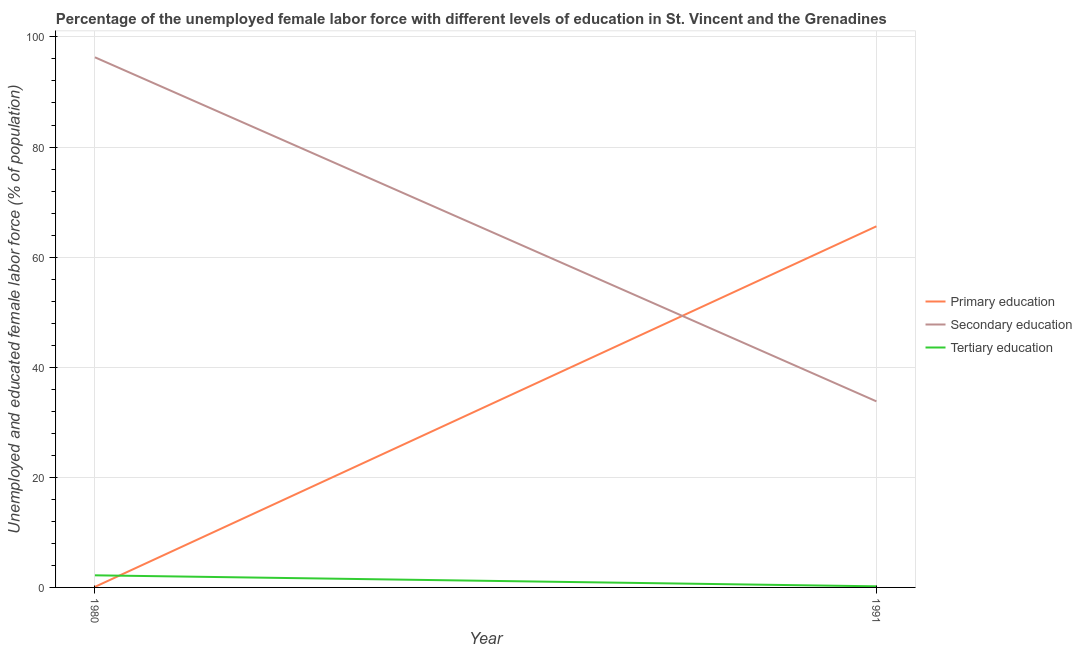How many different coloured lines are there?
Your answer should be compact. 3. Is the number of lines equal to the number of legend labels?
Your response must be concise. Yes. What is the percentage of female labor force who received tertiary education in 1980?
Ensure brevity in your answer.  2.2. Across all years, what is the maximum percentage of female labor force who received secondary education?
Give a very brief answer. 96.3. Across all years, what is the minimum percentage of female labor force who received secondary education?
Your answer should be compact. 33.8. What is the total percentage of female labor force who received primary education in the graph?
Your answer should be very brief. 65.7. What is the difference between the percentage of female labor force who received tertiary education in 1980 and that in 1991?
Your answer should be compact. 2. What is the difference between the percentage of female labor force who received primary education in 1980 and the percentage of female labor force who received tertiary education in 1991?
Offer a terse response. -0.1. What is the average percentage of female labor force who received secondary education per year?
Provide a succinct answer. 65.05. In the year 1991, what is the difference between the percentage of female labor force who received secondary education and percentage of female labor force who received primary education?
Provide a short and direct response. -31.8. In how many years, is the percentage of female labor force who received primary education greater than 76 %?
Provide a succinct answer. 0. What is the ratio of the percentage of female labor force who received primary education in 1980 to that in 1991?
Your response must be concise. 0. Is it the case that in every year, the sum of the percentage of female labor force who received primary education and percentage of female labor force who received secondary education is greater than the percentage of female labor force who received tertiary education?
Provide a succinct answer. Yes. Does the percentage of female labor force who received primary education monotonically increase over the years?
Provide a short and direct response. Yes. Is the percentage of female labor force who received tertiary education strictly less than the percentage of female labor force who received secondary education over the years?
Ensure brevity in your answer.  Yes. Are the values on the major ticks of Y-axis written in scientific E-notation?
Provide a short and direct response. No. Does the graph contain any zero values?
Provide a short and direct response. No. Does the graph contain grids?
Give a very brief answer. Yes. How many legend labels are there?
Your response must be concise. 3. How are the legend labels stacked?
Provide a short and direct response. Vertical. What is the title of the graph?
Offer a very short reply. Percentage of the unemployed female labor force with different levels of education in St. Vincent and the Grenadines. What is the label or title of the X-axis?
Your answer should be compact. Year. What is the label or title of the Y-axis?
Make the answer very short. Unemployed and educated female labor force (% of population). What is the Unemployed and educated female labor force (% of population) in Primary education in 1980?
Offer a terse response. 0.1. What is the Unemployed and educated female labor force (% of population) of Secondary education in 1980?
Give a very brief answer. 96.3. What is the Unemployed and educated female labor force (% of population) in Tertiary education in 1980?
Provide a succinct answer. 2.2. What is the Unemployed and educated female labor force (% of population) of Primary education in 1991?
Ensure brevity in your answer.  65.6. What is the Unemployed and educated female labor force (% of population) of Secondary education in 1991?
Provide a succinct answer. 33.8. What is the Unemployed and educated female labor force (% of population) in Tertiary education in 1991?
Your response must be concise. 0.2. Across all years, what is the maximum Unemployed and educated female labor force (% of population) of Primary education?
Offer a terse response. 65.6. Across all years, what is the maximum Unemployed and educated female labor force (% of population) of Secondary education?
Make the answer very short. 96.3. Across all years, what is the maximum Unemployed and educated female labor force (% of population) of Tertiary education?
Provide a short and direct response. 2.2. Across all years, what is the minimum Unemployed and educated female labor force (% of population) of Primary education?
Provide a short and direct response. 0.1. Across all years, what is the minimum Unemployed and educated female labor force (% of population) in Secondary education?
Ensure brevity in your answer.  33.8. Across all years, what is the minimum Unemployed and educated female labor force (% of population) of Tertiary education?
Make the answer very short. 0.2. What is the total Unemployed and educated female labor force (% of population) of Primary education in the graph?
Make the answer very short. 65.7. What is the total Unemployed and educated female labor force (% of population) of Secondary education in the graph?
Provide a short and direct response. 130.1. What is the difference between the Unemployed and educated female labor force (% of population) of Primary education in 1980 and that in 1991?
Ensure brevity in your answer.  -65.5. What is the difference between the Unemployed and educated female labor force (% of population) in Secondary education in 1980 and that in 1991?
Provide a short and direct response. 62.5. What is the difference between the Unemployed and educated female labor force (% of population) in Primary education in 1980 and the Unemployed and educated female labor force (% of population) in Secondary education in 1991?
Provide a short and direct response. -33.7. What is the difference between the Unemployed and educated female labor force (% of population) in Secondary education in 1980 and the Unemployed and educated female labor force (% of population) in Tertiary education in 1991?
Provide a short and direct response. 96.1. What is the average Unemployed and educated female labor force (% of population) of Primary education per year?
Give a very brief answer. 32.85. What is the average Unemployed and educated female labor force (% of population) of Secondary education per year?
Offer a terse response. 65.05. In the year 1980, what is the difference between the Unemployed and educated female labor force (% of population) in Primary education and Unemployed and educated female labor force (% of population) in Secondary education?
Offer a very short reply. -96.2. In the year 1980, what is the difference between the Unemployed and educated female labor force (% of population) in Secondary education and Unemployed and educated female labor force (% of population) in Tertiary education?
Provide a succinct answer. 94.1. In the year 1991, what is the difference between the Unemployed and educated female labor force (% of population) in Primary education and Unemployed and educated female labor force (% of population) in Secondary education?
Offer a terse response. 31.8. In the year 1991, what is the difference between the Unemployed and educated female labor force (% of population) in Primary education and Unemployed and educated female labor force (% of population) in Tertiary education?
Offer a very short reply. 65.4. In the year 1991, what is the difference between the Unemployed and educated female labor force (% of population) in Secondary education and Unemployed and educated female labor force (% of population) in Tertiary education?
Provide a short and direct response. 33.6. What is the ratio of the Unemployed and educated female labor force (% of population) in Primary education in 1980 to that in 1991?
Make the answer very short. 0. What is the ratio of the Unemployed and educated female labor force (% of population) of Secondary education in 1980 to that in 1991?
Your answer should be compact. 2.85. What is the difference between the highest and the second highest Unemployed and educated female labor force (% of population) in Primary education?
Provide a short and direct response. 65.5. What is the difference between the highest and the second highest Unemployed and educated female labor force (% of population) in Secondary education?
Provide a short and direct response. 62.5. What is the difference between the highest and the second highest Unemployed and educated female labor force (% of population) in Tertiary education?
Your answer should be very brief. 2. What is the difference between the highest and the lowest Unemployed and educated female labor force (% of population) of Primary education?
Give a very brief answer. 65.5. What is the difference between the highest and the lowest Unemployed and educated female labor force (% of population) of Secondary education?
Make the answer very short. 62.5. What is the difference between the highest and the lowest Unemployed and educated female labor force (% of population) in Tertiary education?
Your answer should be very brief. 2. 